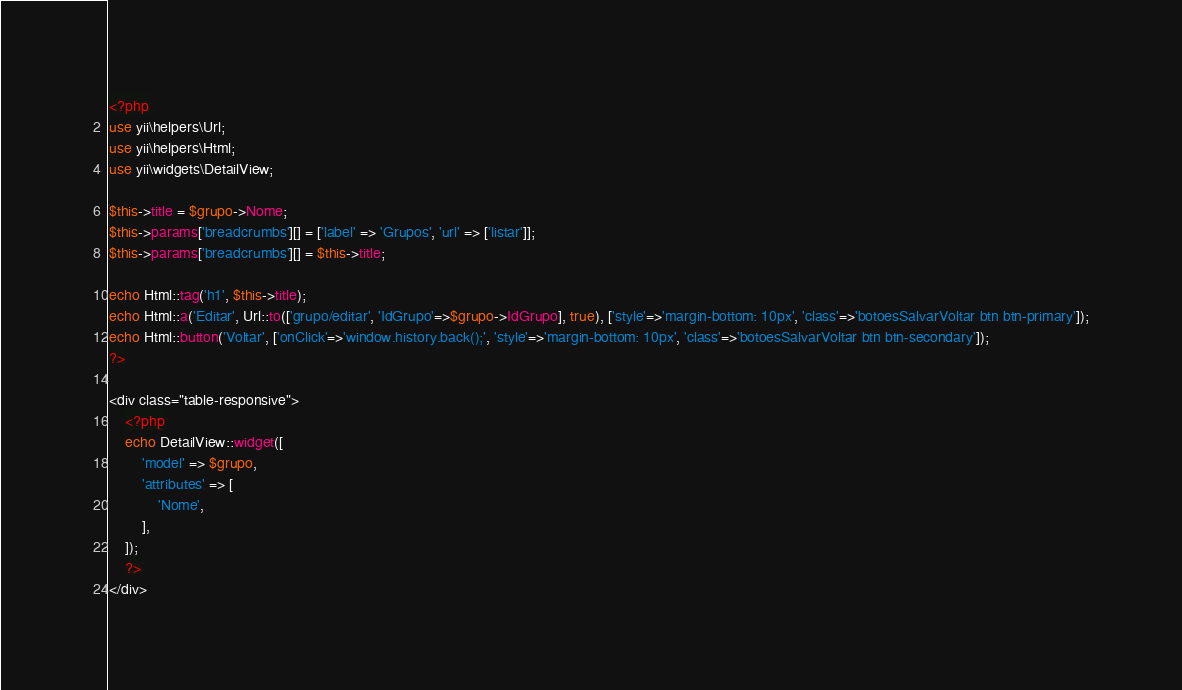Convert code to text. <code><loc_0><loc_0><loc_500><loc_500><_PHP_><?php
use yii\helpers\Url;
use yii\helpers\Html;
use yii\widgets\DetailView;

$this->title = $grupo->Nome;
$this->params['breadcrumbs'][] = ['label' => 'Grupos', 'url' => ['listar']];
$this->params['breadcrumbs'][] = $this->title;

echo Html::tag('h1', $this->title);
echo Html::a('Editar', Url::to(['grupo/editar', 'IdGrupo'=>$grupo->IdGrupo], true), ['style'=>'margin-bottom: 10px', 'class'=>'botoesSalvarVoltar btn btn-primary']);
echo Html::button('Voltar', ['onClick'=>'window.history.back();', 'style'=>'margin-bottom: 10px', 'class'=>'botoesSalvarVoltar btn btn-secondary']);
?>

<div class="table-responsive">
    <?php
    echo DetailView::widget([
        'model' => $grupo,
        'attributes' => [
            'Nome',
        ],
    ]);
    ?>
</div>
</code> 